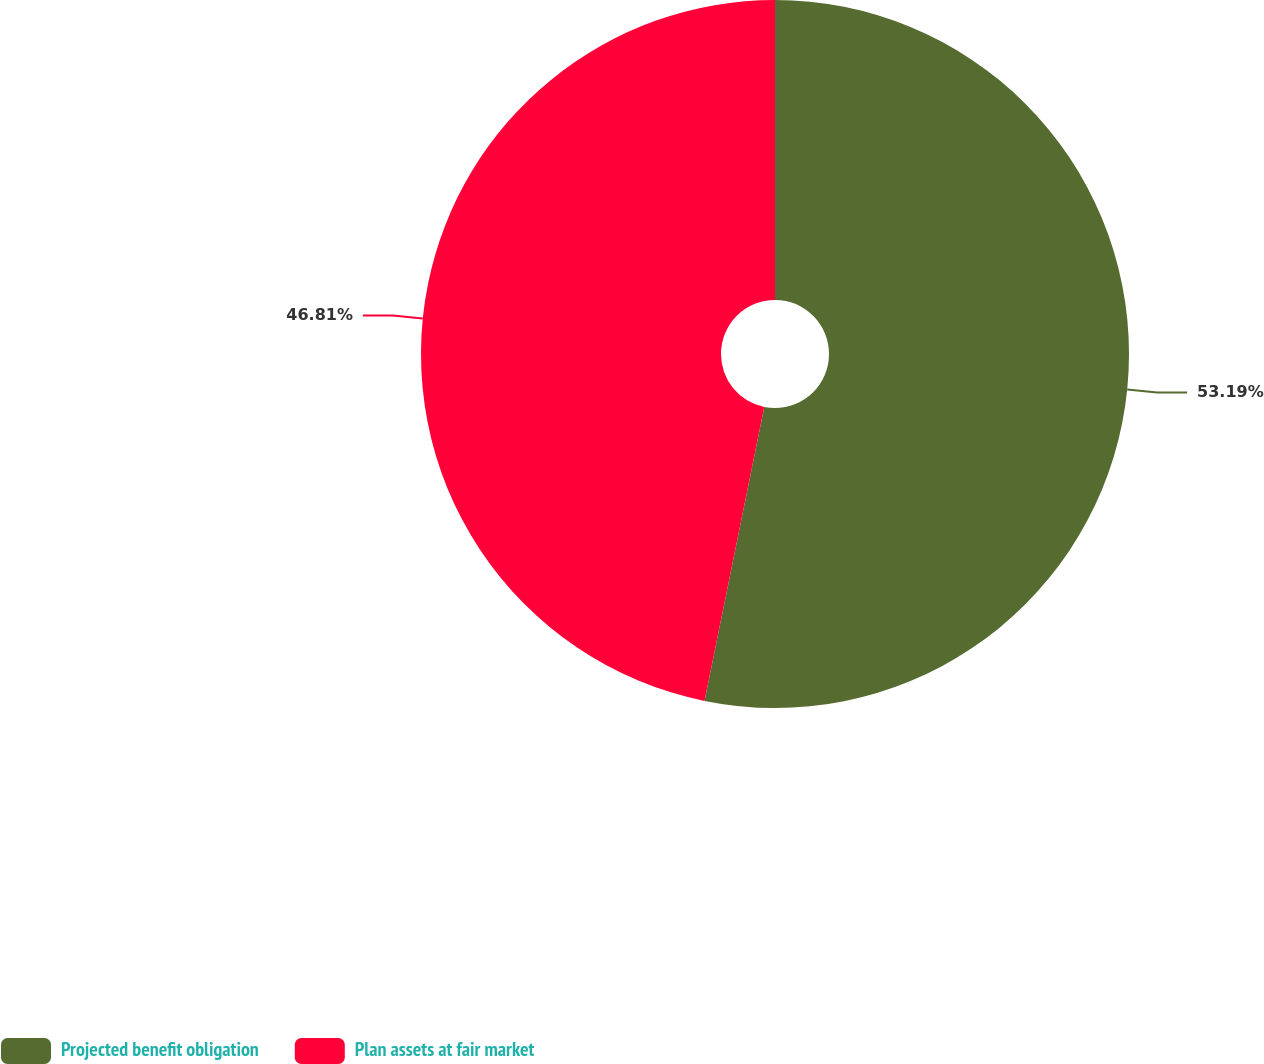<chart> <loc_0><loc_0><loc_500><loc_500><pie_chart><fcel>Projected benefit obligation<fcel>Plan assets at fair market<nl><fcel>53.19%<fcel>46.81%<nl></chart> 